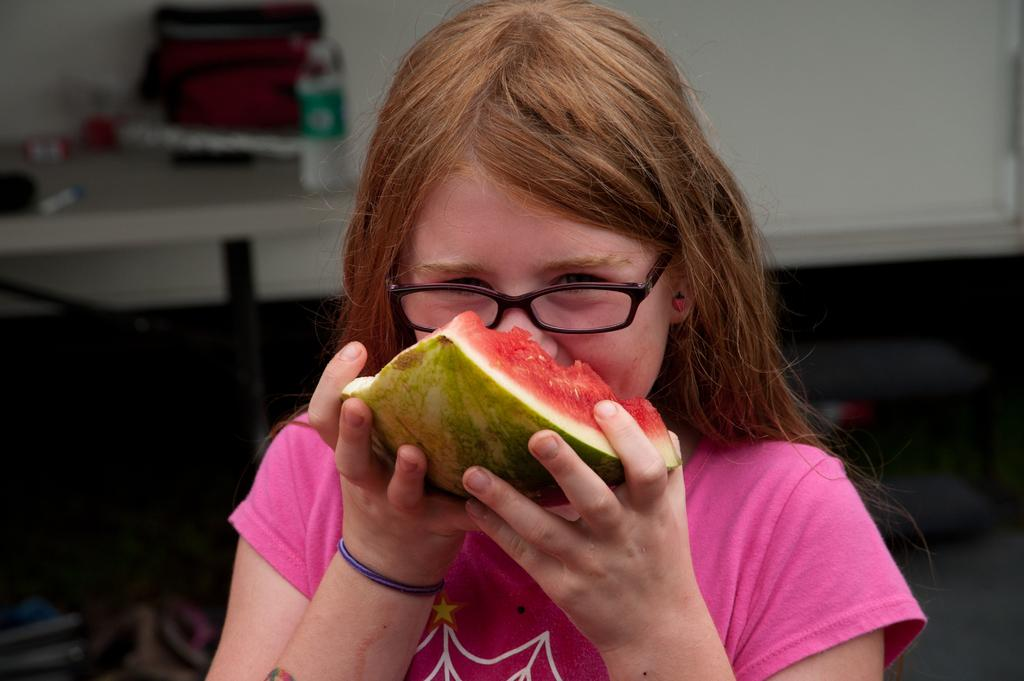Who is the main subject in the image? There is a person in the image. What is the person doing in the image? The person is eating a watermelon. What can be seen in the background of the image? There is a water bottle, a bag, a pen, objects on a table, and objects on the floor in the background of the image. What type of wax can be seen melting on the person's face in the image? There is no wax present in the image; the person is eating a watermelon. 